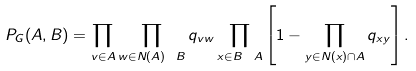Convert formula to latex. <formula><loc_0><loc_0><loc_500><loc_500>P _ { G } ( A , B ) = \prod _ { v \in A } \prod _ { w \in N ( A ) \ B } q _ { v w } \prod _ { x \in B \ A } \left [ 1 - \prod _ { y \in N ( x ) \cap A } q _ { x y } \right ] .</formula> 